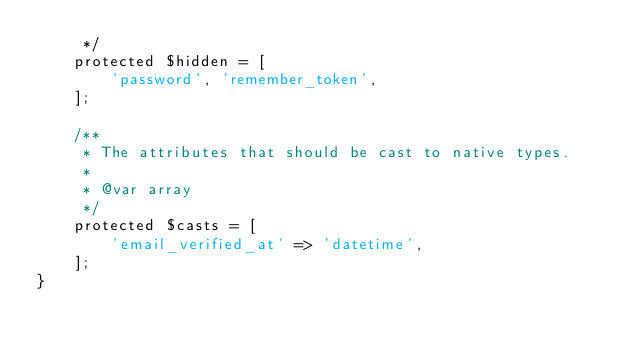<code> <loc_0><loc_0><loc_500><loc_500><_PHP_>     */
    protected $hidden = [
        'password', 'remember_token',
    ];

    /**
     * The attributes that should be cast to native types.
     *
     * @var array
     */
    protected $casts = [
        'email_verified_at' => 'datetime',
    ];
}
</code> 